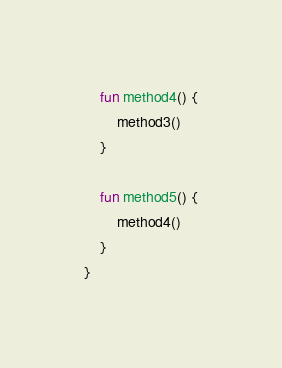Convert code to text. <code><loc_0><loc_0><loc_500><loc_500><_Kotlin_>    fun method4() {
        method3()
    }

    fun method5() {
        method4()
    }
}
</code> 